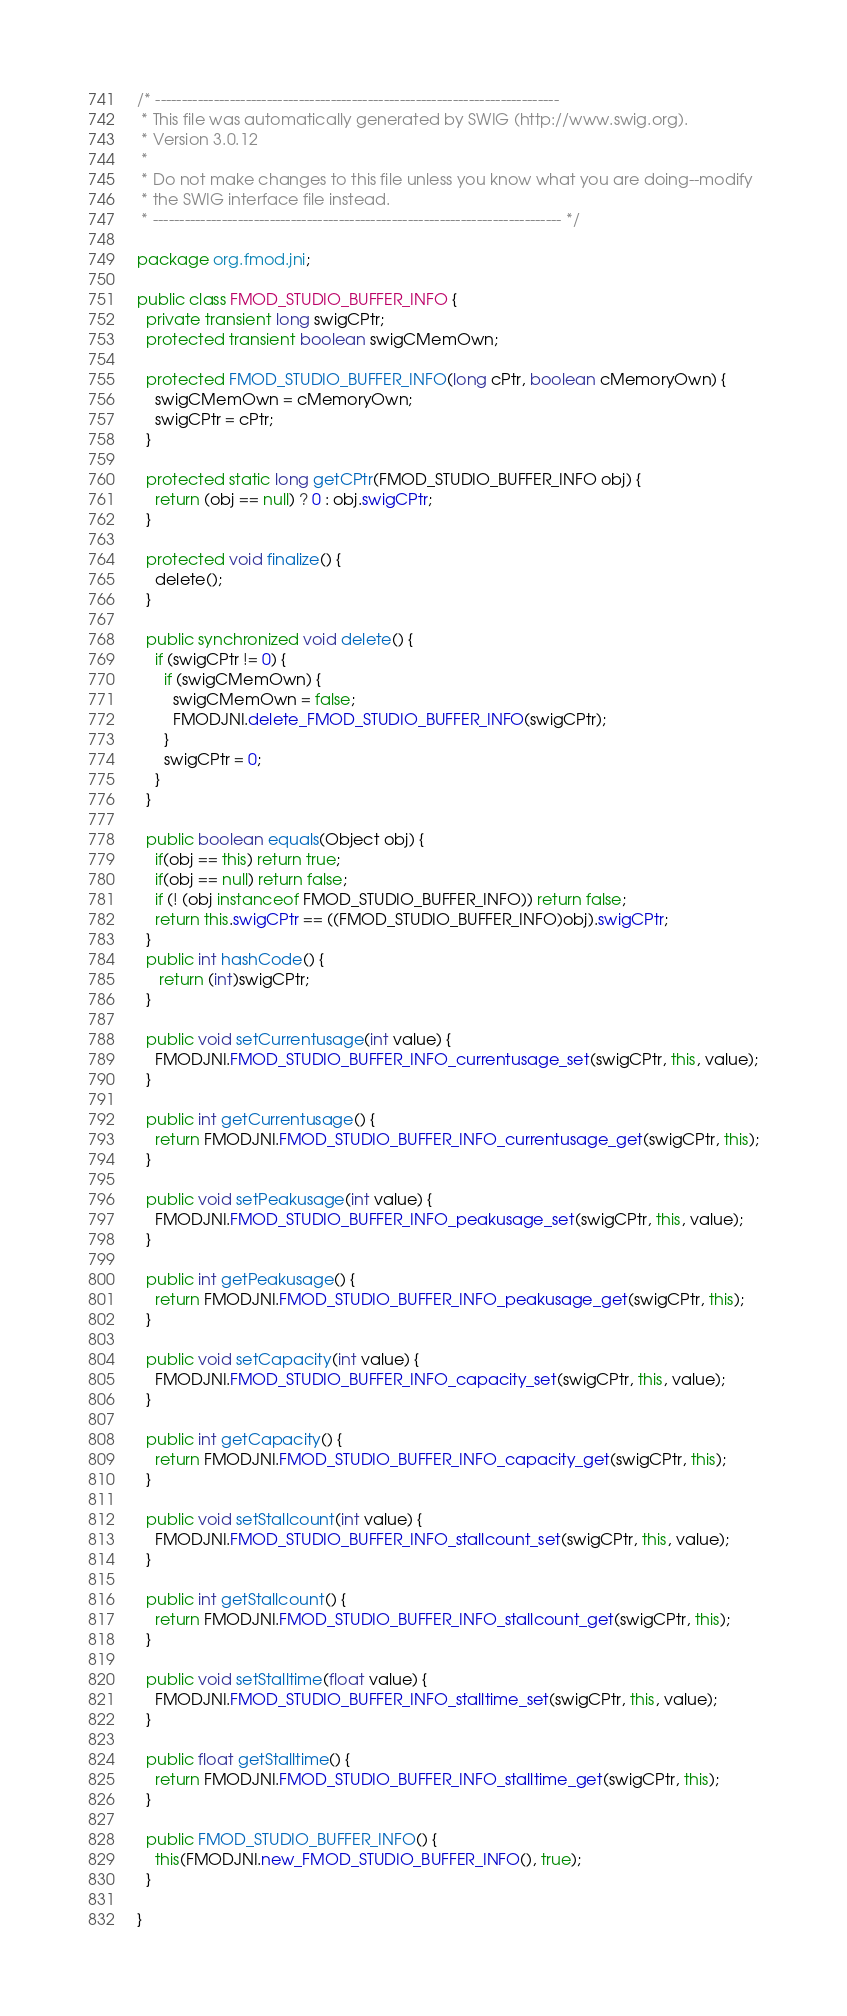<code> <loc_0><loc_0><loc_500><loc_500><_Java_>/* ----------------------------------------------------------------------------
 * This file was automatically generated by SWIG (http://www.swig.org).
 * Version 3.0.12
 *
 * Do not make changes to this file unless you know what you are doing--modify
 * the SWIG interface file instead.
 * ----------------------------------------------------------------------------- */

package org.fmod.jni;

public class FMOD_STUDIO_BUFFER_INFO {
  private transient long swigCPtr;
  protected transient boolean swigCMemOwn;

  protected FMOD_STUDIO_BUFFER_INFO(long cPtr, boolean cMemoryOwn) {
    swigCMemOwn = cMemoryOwn;
    swigCPtr = cPtr;
  }

  protected static long getCPtr(FMOD_STUDIO_BUFFER_INFO obj) {
    return (obj == null) ? 0 : obj.swigCPtr;
  }

  protected void finalize() {
    delete();
  }

  public synchronized void delete() {
    if (swigCPtr != 0) {
      if (swigCMemOwn) {
        swigCMemOwn = false;
        FMODJNI.delete_FMOD_STUDIO_BUFFER_INFO(swigCPtr);
      }
      swigCPtr = 0;
    }
  }

  public boolean equals(Object obj) {
  	if(obj == this) return true;
  	if(obj == null) return false;
  	if (! (obj instanceof FMOD_STUDIO_BUFFER_INFO)) return false;
    return this.swigCPtr == ((FMOD_STUDIO_BUFFER_INFO)obj).swigCPtr;
  }
  public int hashCode() {
     return (int)swigCPtr;
  }

  public void setCurrentusage(int value) {
    FMODJNI.FMOD_STUDIO_BUFFER_INFO_currentusage_set(swigCPtr, this, value);
  }

  public int getCurrentusage() {
    return FMODJNI.FMOD_STUDIO_BUFFER_INFO_currentusage_get(swigCPtr, this);
  }

  public void setPeakusage(int value) {
    FMODJNI.FMOD_STUDIO_BUFFER_INFO_peakusage_set(swigCPtr, this, value);
  }

  public int getPeakusage() {
    return FMODJNI.FMOD_STUDIO_BUFFER_INFO_peakusage_get(swigCPtr, this);
  }

  public void setCapacity(int value) {
    FMODJNI.FMOD_STUDIO_BUFFER_INFO_capacity_set(swigCPtr, this, value);
  }

  public int getCapacity() {
    return FMODJNI.FMOD_STUDIO_BUFFER_INFO_capacity_get(swigCPtr, this);
  }

  public void setStallcount(int value) {
    FMODJNI.FMOD_STUDIO_BUFFER_INFO_stallcount_set(swigCPtr, this, value);
  }

  public int getStallcount() {
    return FMODJNI.FMOD_STUDIO_BUFFER_INFO_stallcount_get(swigCPtr, this);
  }

  public void setStalltime(float value) {
    FMODJNI.FMOD_STUDIO_BUFFER_INFO_stalltime_set(swigCPtr, this, value);
  }

  public float getStalltime() {
    return FMODJNI.FMOD_STUDIO_BUFFER_INFO_stalltime_get(swigCPtr, this);
  }

  public FMOD_STUDIO_BUFFER_INFO() {
    this(FMODJNI.new_FMOD_STUDIO_BUFFER_INFO(), true);
  }

}
</code> 